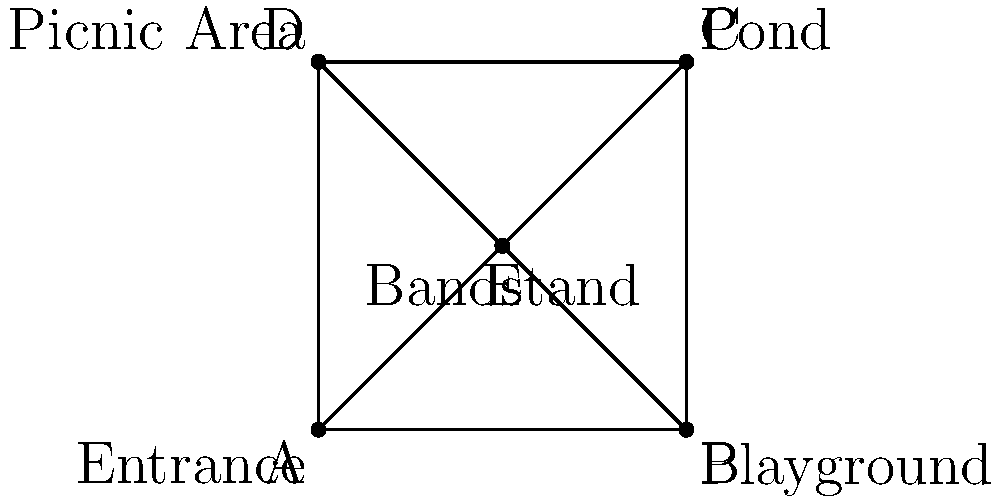Based on the simplified map of Elmore Park shown above, what feature is located at the center of the park (point E)? To answer this question, we need to analyze the simplified map of Elmore Park:

1. The map shows a square-shaped park with four corners labeled A, B, C, and D.
2. These corners represent different features of the park:
   - A (bottom-left): Entrance
   - B (bottom-right): Playground
   - C (top-right): Pond
   - D (top-left): Picnic Area
3. There is a point E located at the center of the square, where the diagonal lines intersect.
4. This central point E is labeled as "Bandstand" on the map.

Therefore, the feature located at the center of Elmore Park (point E) is the Bandstand.
Answer: Bandstand 